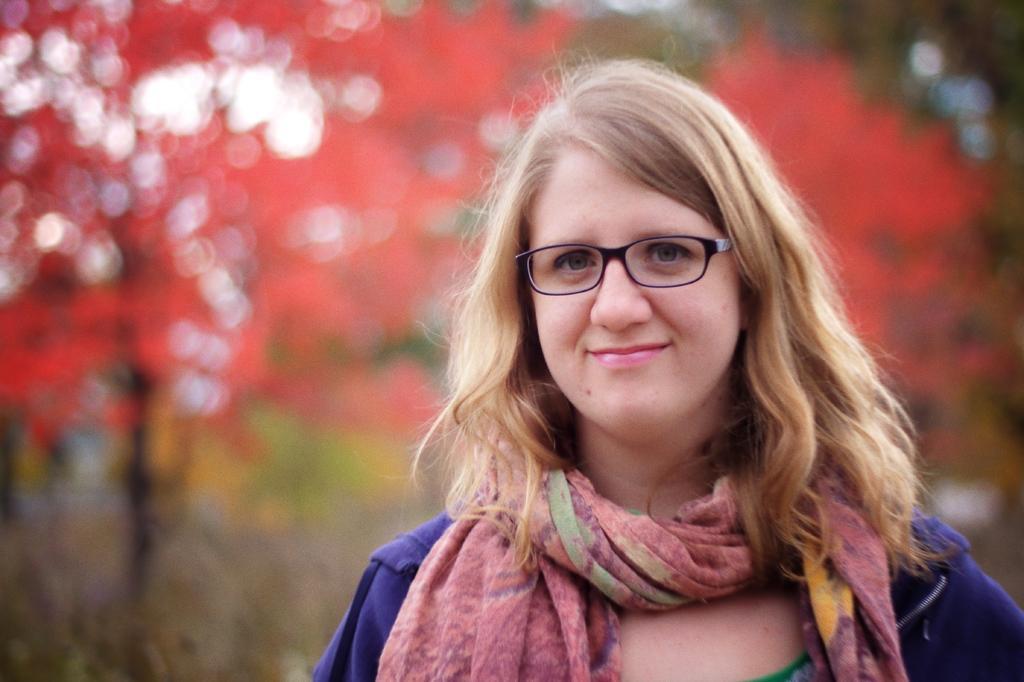Please provide a concise description of this image. In this image I can see a woman, I can see she is wearing specs, purple colour jacket and a scarf. I can also see smile on her face and in the background I can see orange colour. I can also see this image is little bit blurry from background. 